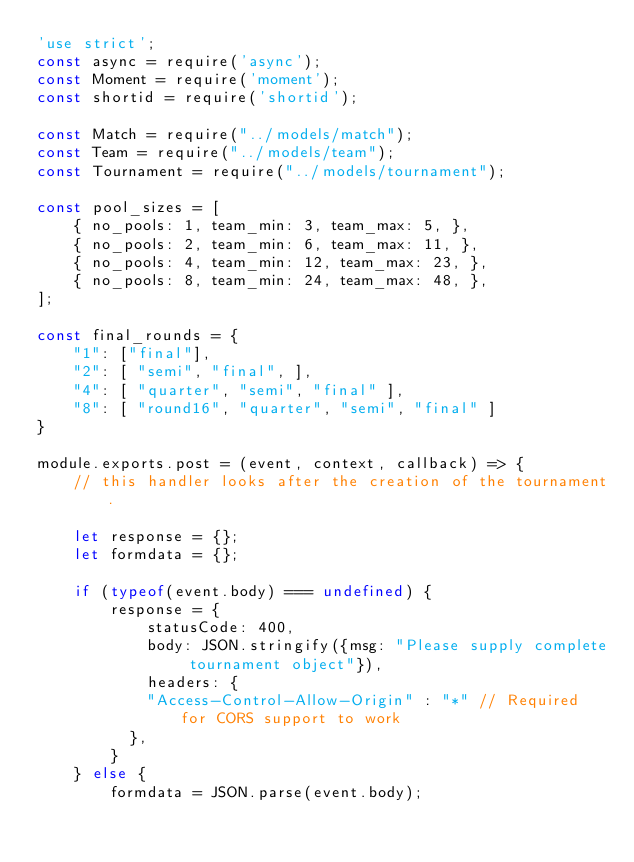Convert code to text. <code><loc_0><loc_0><loc_500><loc_500><_JavaScript_>'use strict';
const async = require('async');
const Moment = require('moment');
const shortid = require('shortid');

const Match = require("../models/match");
const Team = require("../models/team");
const Tournament = require("../models/tournament");

const pool_sizes = [
    { no_pools: 1, team_min: 3, team_max: 5, },
    { no_pools: 2, team_min: 6, team_max: 11, },
    { no_pools: 4, team_min: 12, team_max: 23, },
    { no_pools: 8, team_min: 24, team_max: 48, },
];

const final_rounds = {
    "1": ["final"],
    "2": [ "semi", "final", ],
    "4": [ "quarter", "semi", "final" ],
    "8": [ "round16", "quarter", "semi", "final" ]
}

module.exports.post = (event, context, callback) => {
    // this handler looks after the creation of the tournament.

    let response = {};
    let formdata = {};

    if (typeof(event.body) === undefined) {
        response = {
            statusCode: 400,
            body: JSON.stringify({msg: "Please supply complete tournament object"}),
            headers: {
        		"Access-Control-Allow-Origin" : "*" // Required for CORS support to work
      		},
        }
    } else {
        formdata = JSON.parse(event.body);
</code> 